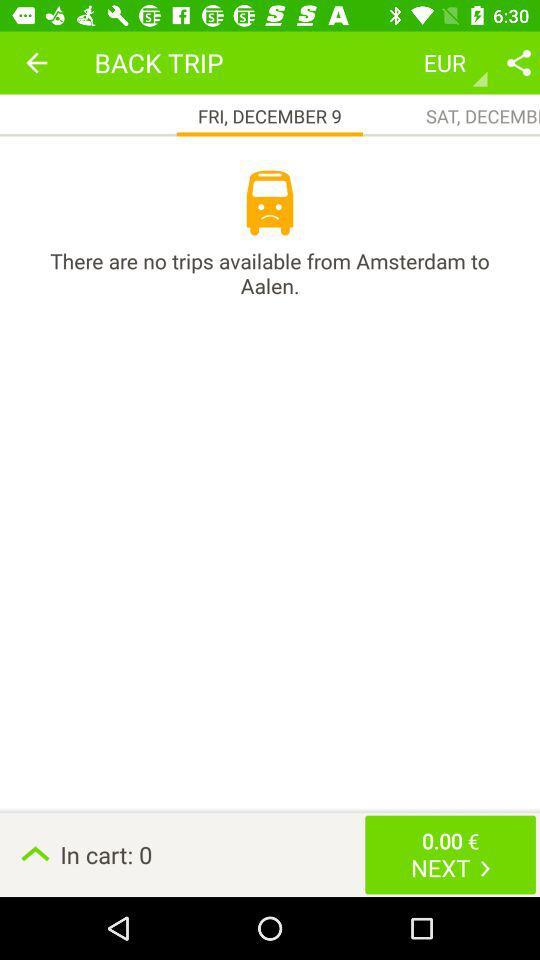How many trips are available from Amsterdam to Aalen? There are no trips available from Amsterdam to Aalen. 